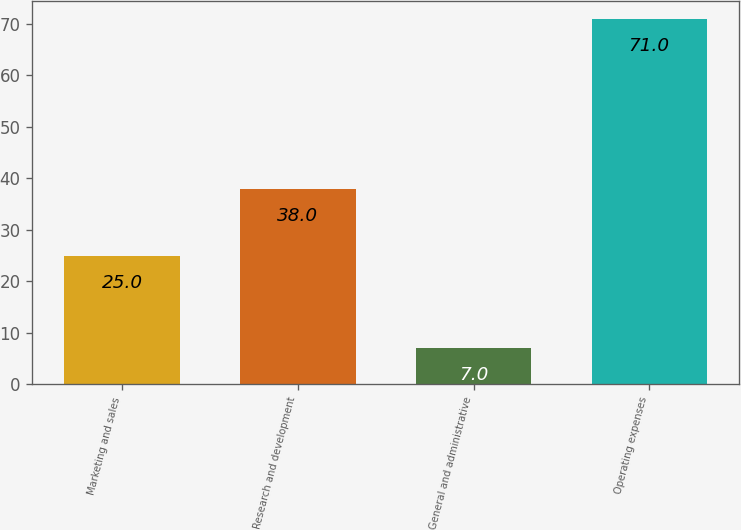<chart> <loc_0><loc_0><loc_500><loc_500><bar_chart><fcel>Marketing and sales<fcel>Research and development<fcel>General and administrative<fcel>Operating expenses<nl><fcel>25<fcel>38<fcel>7<fcel>71<nl></chart> 